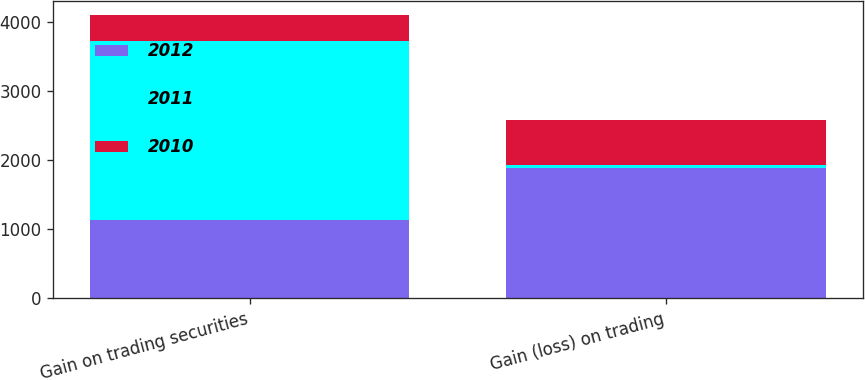Convert chart to OTSL. <chart><loc_0><loc_0><loc_500><loc_500><stacked_bar_chart><ecel><fcel>Gain on trading securities<fcel>Gain (loss) on trading<nl><fcel>2012<fcel>1130<fcel>1883<nl><fcel>2011<fcel>2604<fcel>44<nl><fcel>2010<fcel>375<fcel>662.5<nl></chart> 